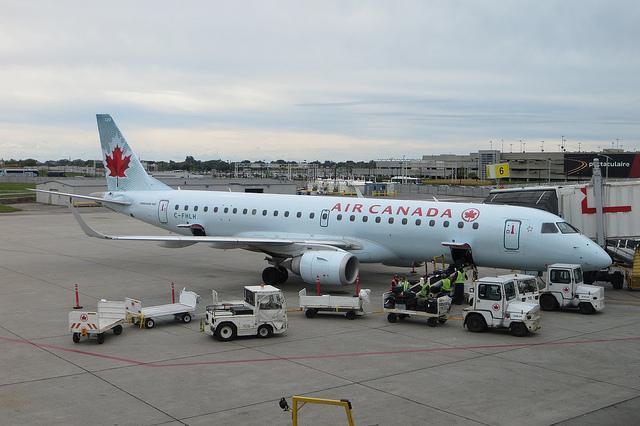How many people are boarding the plane?
Give a very brief answer. 0. How many trucks are in the photo?
Give a very brief answer. 3. How many chairs are visible?
Give a very brief answer. 0. 